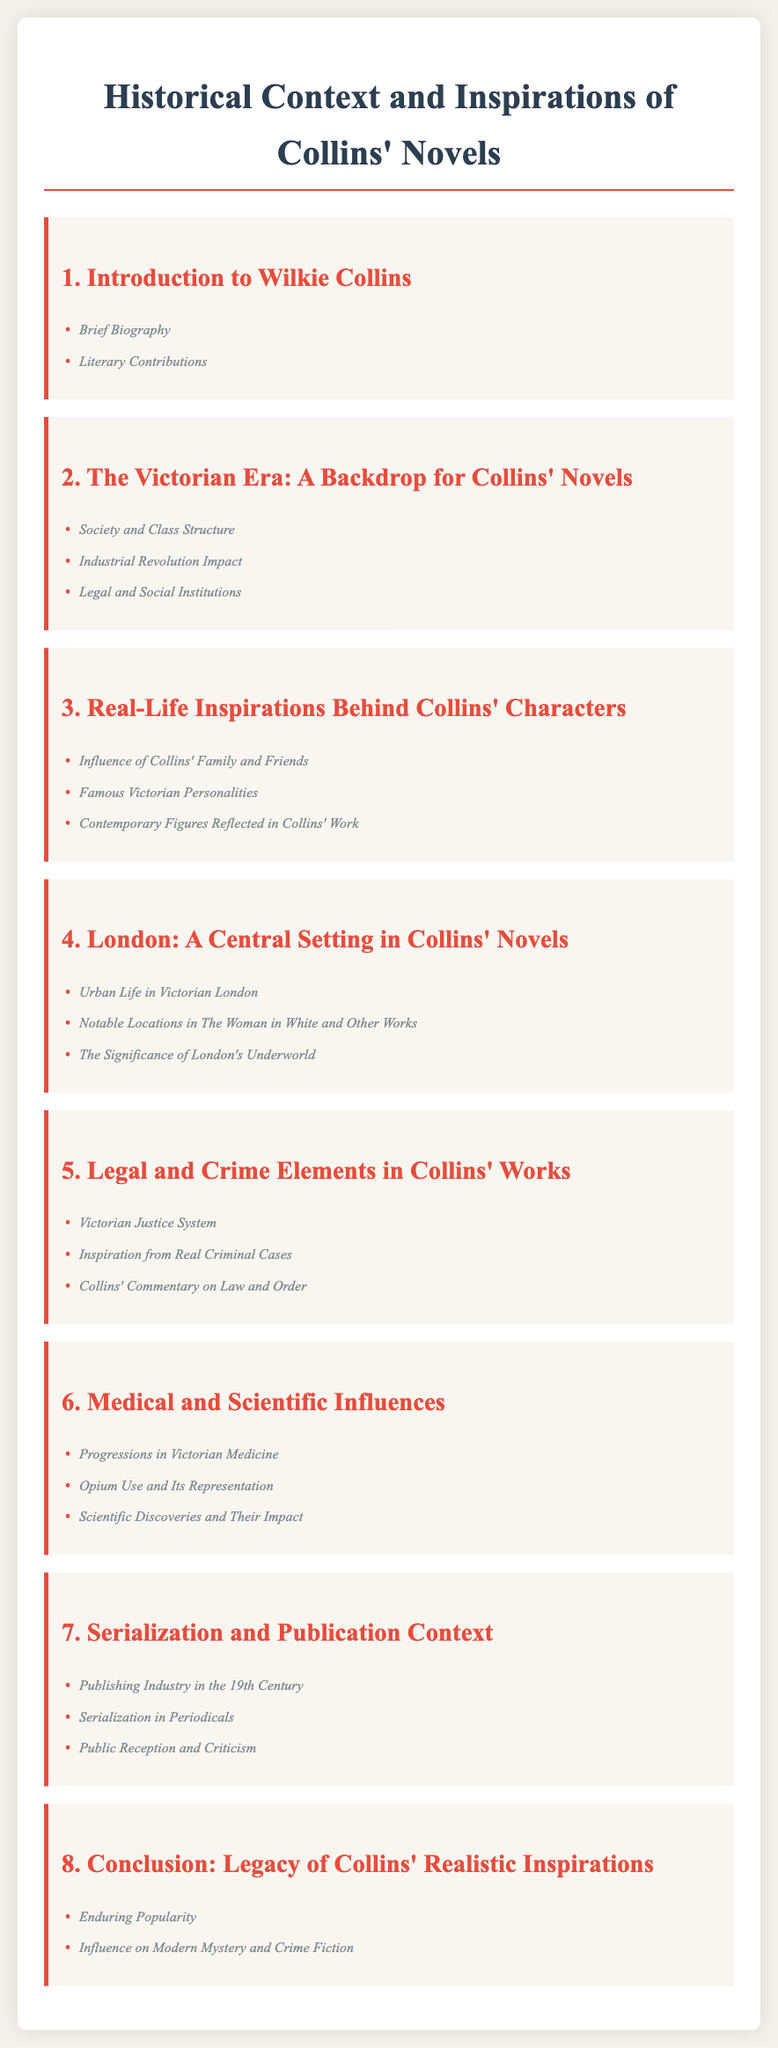What is the title of the document? The title is presented at the top of the document and indicates its focus.
Answer: Historical Context and Inspirations of Collins' Novels How many chapters are in the document? The document lists eight chapters, which can be counted from the table of contents.
Answer: 8 What is the first section under chapter 5? The first section is listed as part of chapter 5 regarding legal elements in Collins' works.
Answer: Victorian Justice System Which city is emphasized as a central setting in Collins' novels? The document clearly mentions the city that serves as a backdrop for many of Collins' stories.
Answer: London What is the last section in the last chapter? The final section under the last chapter summarizes Collins' impact on contemporary writing.
Answer: Influence on Modern Mystery and Crime Fiction Which chapter details the Victorian era's societal structure? The chapter that discusses this aspect is specifically dedicated to the Victorian context.
Answer: The Victorian Era: A Backdrop for Collins' Novels What literary aspect is covered in chapter 2? The focus of this chapter addresses the societal elements at the time Collins was writing.
Answer: Society and Class Structure What medical theme is examined in chapter 6? This section explores specific advancements in medicine relevant to the narratives Collins created.
Answer: Progressions in Victorian Medicine 